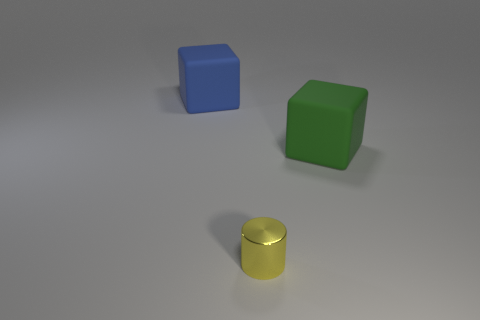Is the size of the thing behind the green object the same as the matte object that is to the right of the blue rubber object?
Give a very brief answer. Yes. There is a rubber object that is behind the green rubber thing on the right side of the yellow cylinder; what is its shape?
Give a very brief answer. Cube. Does the green cube have the same size as the rubber block to the left of the large green rubber cube?
Your response must be concise. Yes. There is a yellow metallic object that is in front of the rubber thing that is on the left side of the cube right of the yellow metal cylinder; what size is it?
Offer a very short reply. Small. How many things are either large matte cubes on the left side of the yellow metallic cylinder or big blue things?
Keep it short and to the point. 1. How many green objects are on the right side of the green block that is on the right side of the yellow cylinder?
Offer a very short reply. 0. Are there more rubber blocks behind the big green block than big blue rubber balls?
Make the answer very short. Yes. There is a thing that is both on the right side of the blue matte object and to the left of the green matte cube; what is its size?
Ensure brevity in your answer.  Small. There is a thing that is behind the yellow metal cylinder and in front of the blue block; what is its shape?
Your response must be concise. Cube. There is a matte thing to the right of the large cube that is on the left side of the small cylinder; is there a large block that is to the left of it?
Your response must be concise. Yes. 